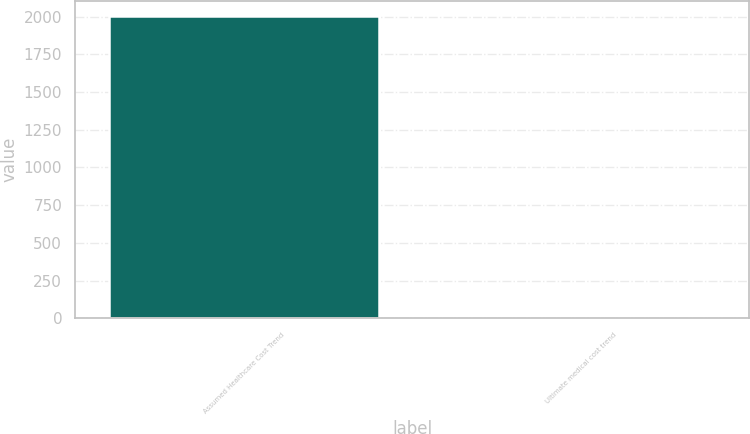Convert chart to OTSL. <chart><loc_0><loc_0><loc_500><loc_500><bar_chart><fcel>Assumed Healthcare Cost Trend<fcel>Ultimate medical cost trend<nl><fcel>2005<fcel>5<nl></chart> 